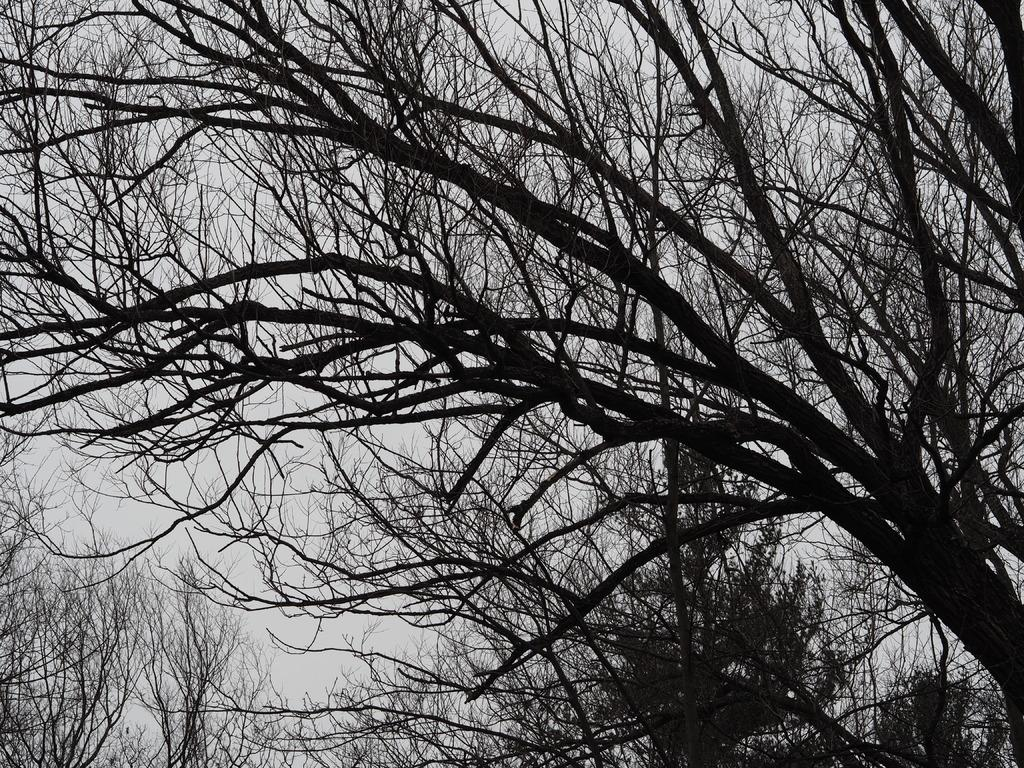What type of vegetation can be seen in the image? There are trees in the image. What part of the natural environment is visible in the image? The sky is visible in the image. What type of question is being asked in the image? There is no question present in the image; it only features trees and the sky. Can you see any bubbles in the image? There are no bubbles present in the image. 